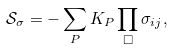Convert formula to latex. <formula><loc_0><loc_0><loc_500><loc_500>\mathcal { S } _ { \sigma } = - \sum _ { P } K _ { P } \prod _ { \Box } \sigma _ { i j } ,</formula> 